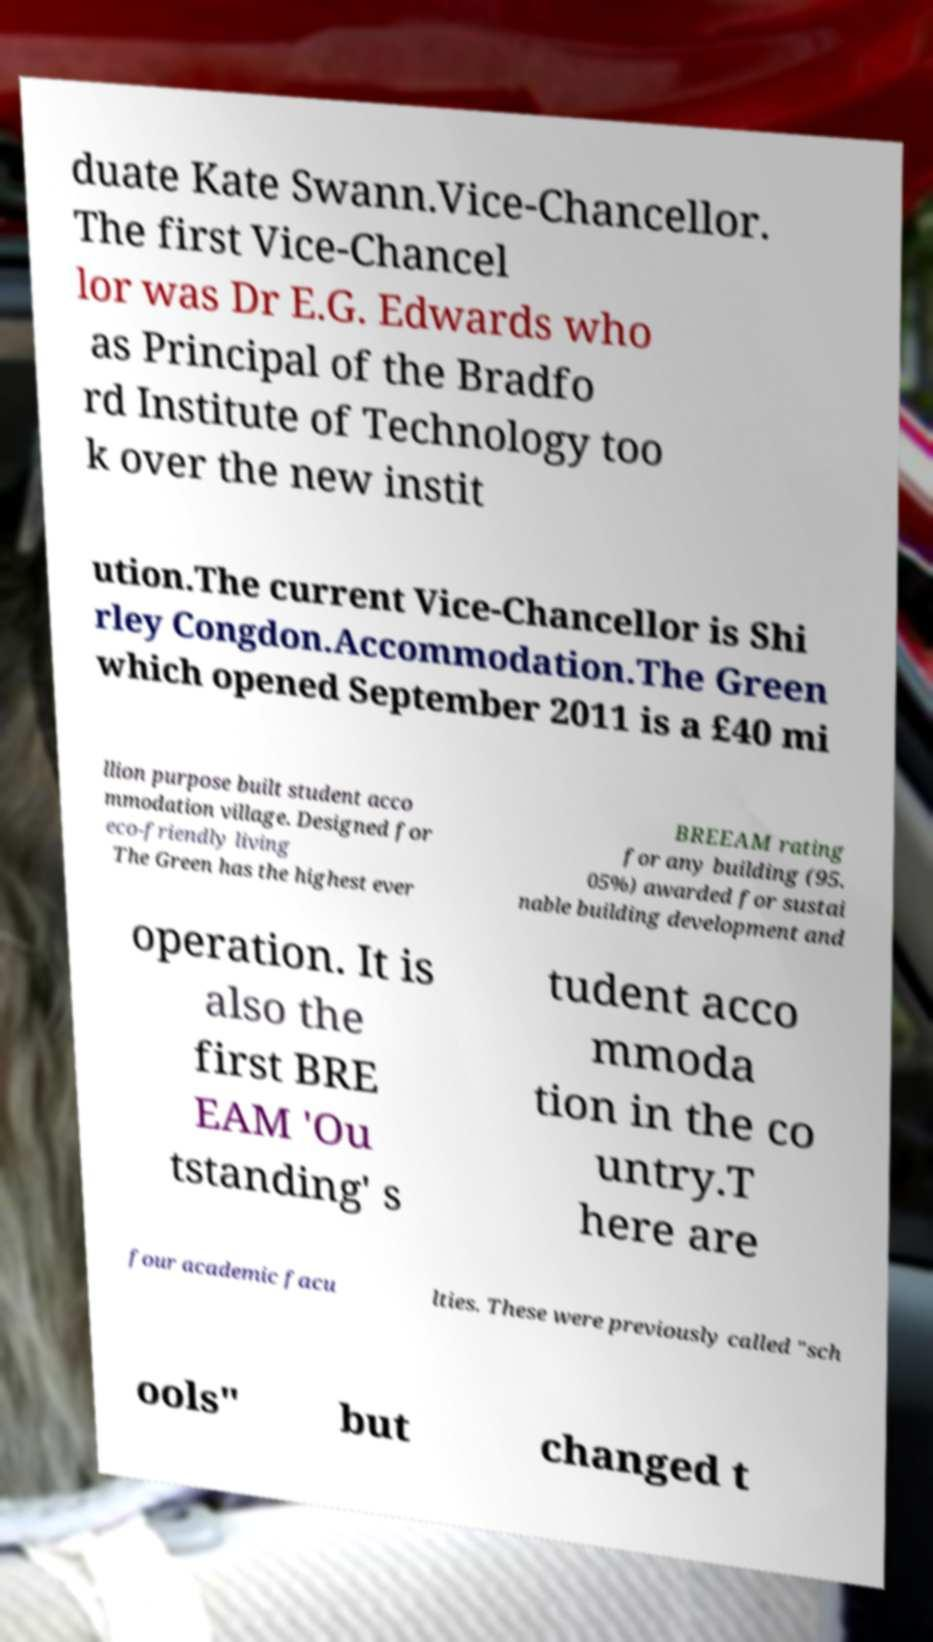Could you assist in decoding the text presented in this image and type it out clearly? duate Kate Swann.Vice-Chancellor. The first Vice-Chancel lor was Dr E.G. Edwards who as Principal of the Bradfo rd Institute of Technology too k over the new instit ution.The current Vice-Chancellor is Shi rley Congdon.Accommodation.The Green which opened September 2011 is a £40 mi llion purpose built student acco mmodation village. Designed for eco-friendly living The Green has the highest ever BREEAM rating for any building (95. 05%) awarded for sustai nable building development and operation. It is also the first BRE EAM 'Ou tstanding' s tudent acco mmoda tion in the co untry.T here are four academic facu lties. These were previously called "sch ools" but changed t 